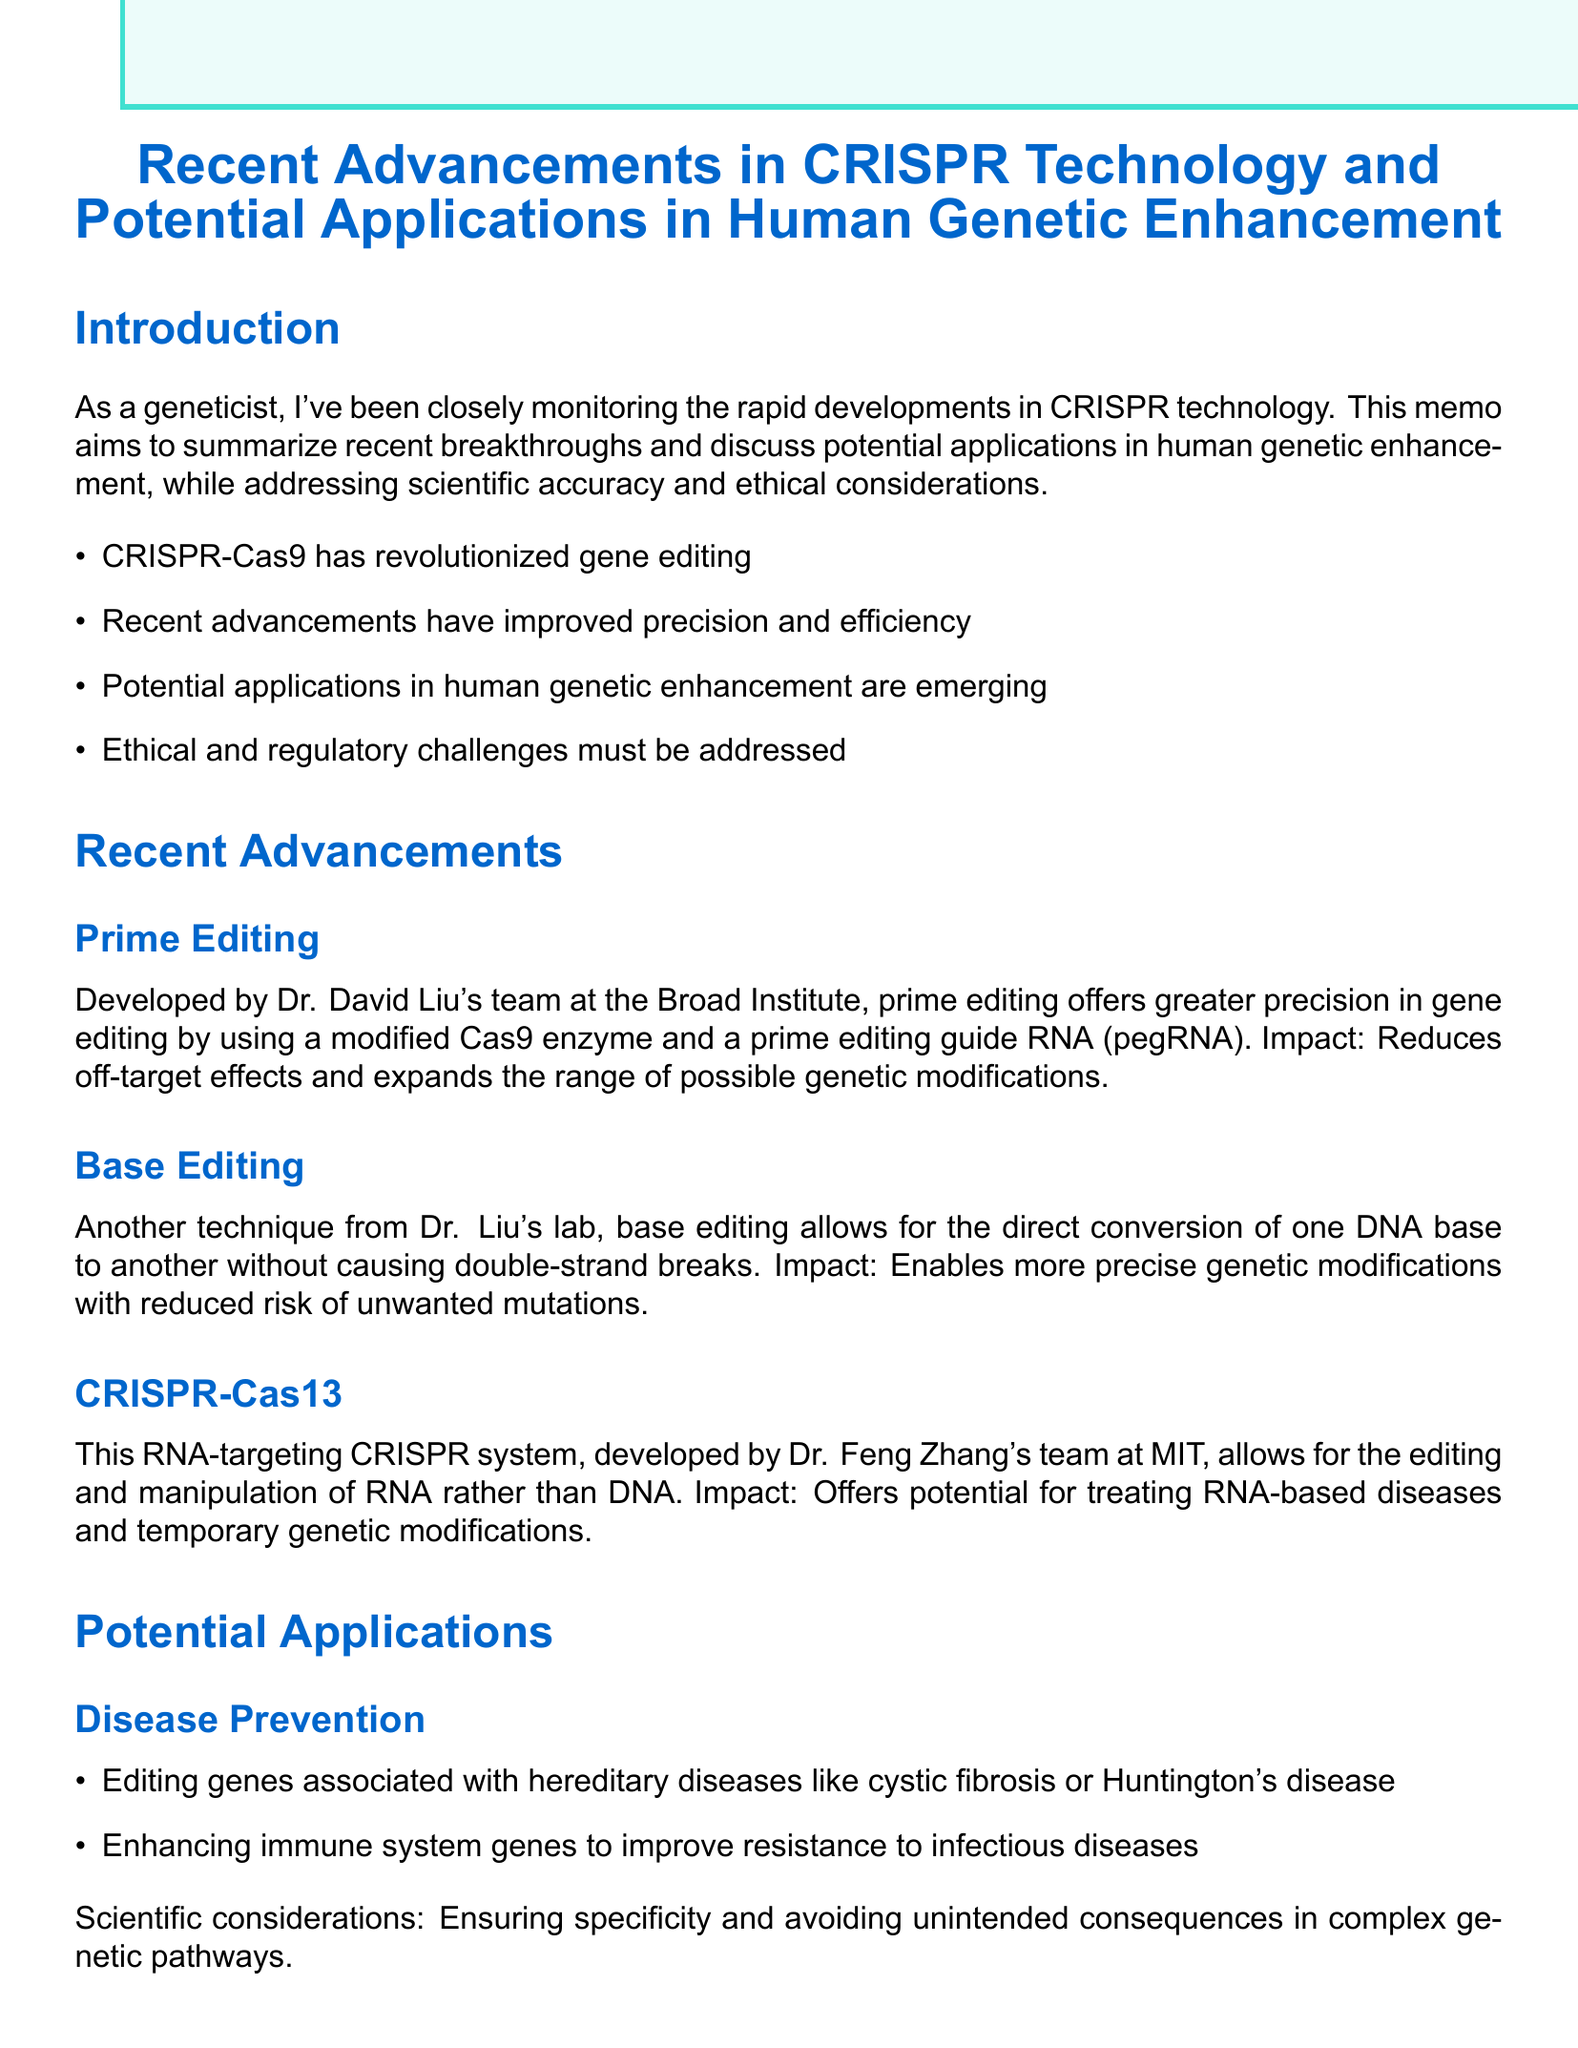What major technology has revolutionized gene editing? The memo states that CRISPR-Cas9 has revolutionized gene editing.
Answer: CRISPR-Cas9 Who developed prime editing? The memo attributes the development of prime editing to Dr. David Liu's team at the Broad Institute.
Answer: Dr. David Liu What area of potential application involves enhancing immune system genes? The area mentioned is Disease Prevention.
Answer: Disease Prevention What technique allows the direct conversion of one DNA base to another? The technique described is base editing.
Answer: Base editing Which organization is mentioned as a key organization in the regulatory landscape? The memo lists National Academies of Sciences, Engineering, and Medicine (NASEM) as a key organization.
Answer: NASEM What is one ethical consideration related to genetic enhancement technologies? The memo mentions ensuring equitable access to genetic enhancement technologies as an ethical consideration.
Answer: Equitable access What is a scientific consideration for cognitive enhancement? The memo refers to the complex interplay of genes and environmental factors in cognitive abilities.
Answer: Complex interplay of genes and environmental factors Which potential application focuses on editing genes related to muscle growth? The potential application area described is Physical Enhancement.
Answer: Physical Enhancement What is the current status of regulations regarding germline editing? The memo states that regulations are varied worldwide, with some countries banning germline editing.
Answer: Varied regulations worldwide 